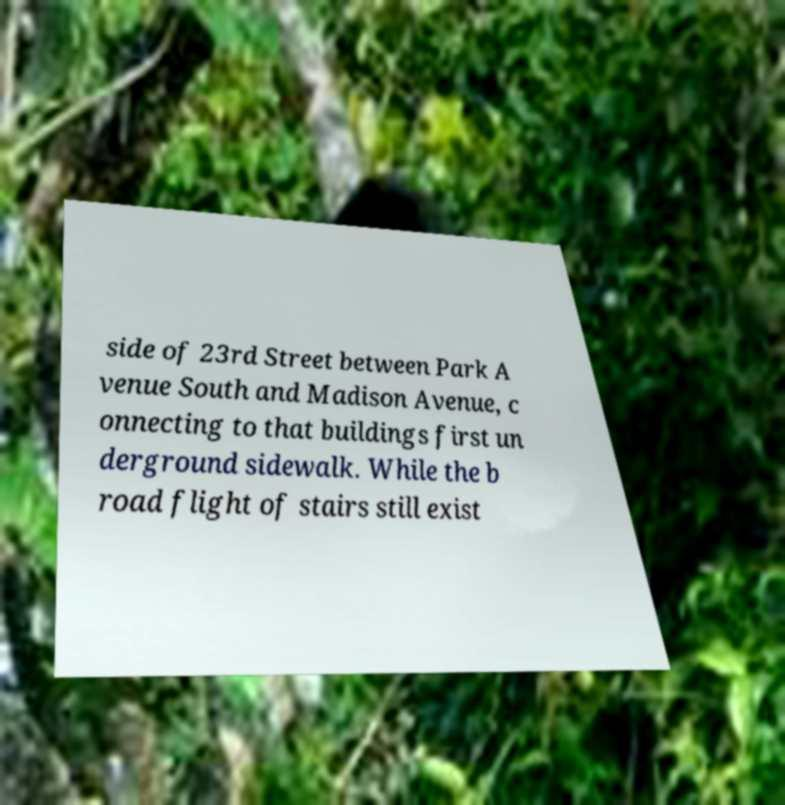Please read and relay the text visible in this image. What does it say? side of 23rd Street between Park A venue South and Madison Avenue, c onnecting to that buildings first un derground sidewalk. While the b road flight of stairs still exist 